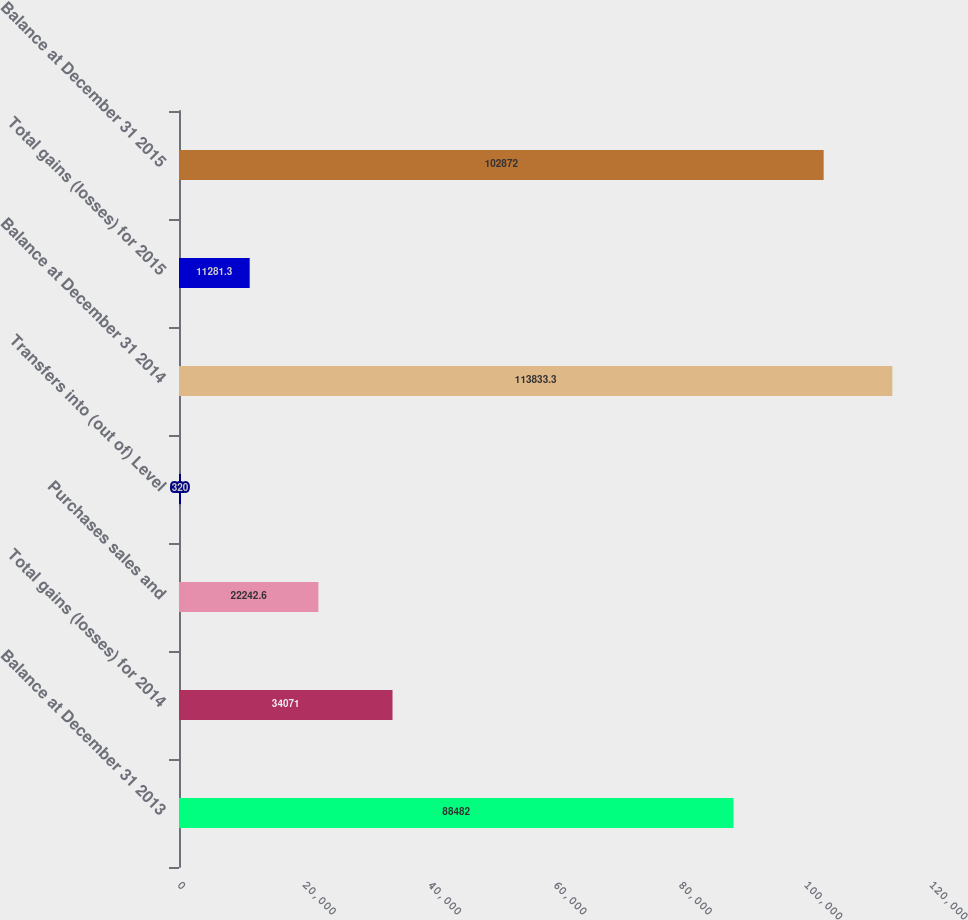Convert chart. <chart><loc_0><loc_0><loc_500><loc_500><bar_chart><fcel>Balance at December 31 2013<fcel>Total gains (losses) for 2014<fcel>Purchases sales and<fcel>Transfers into (out of) Level<fcel>Balance at December 31 2014<fcel>Total gains (losses) for 2015<fcel>Balance at December 31 2015<nl><fcel>88482<fcel>34071<fcel>22242.6<fcel>320<fcel>113833<fcel>11281.3<fcel>102872<nl></chart> 